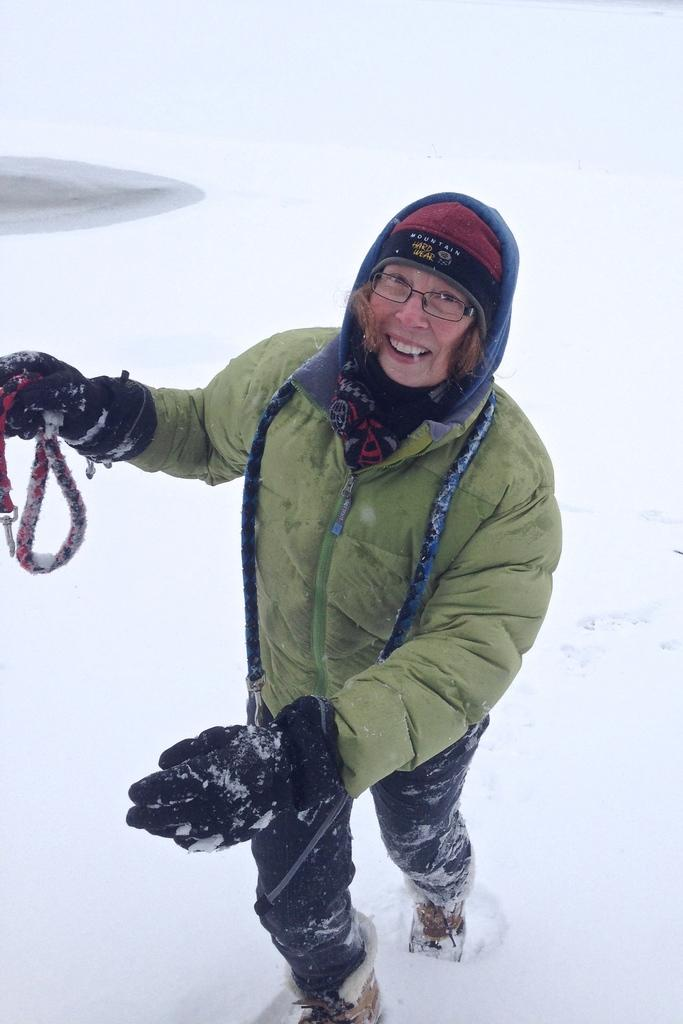What is the person in the image doing? The person is standing in the image. What is the person wearing? The person is wearing a green jacket. What is the person holding? The person is holding something. What can be seen in the background of the image? There is snow visible in the background of the image. What type of metal is the stranger using to hammer in the image? There is no stranger or hammer present in the image. 